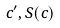Convert formula to latex. <formula><loc_0><loc_0><loc_500><loc_500>c ^ { \prime } , S ( c )</formula> 